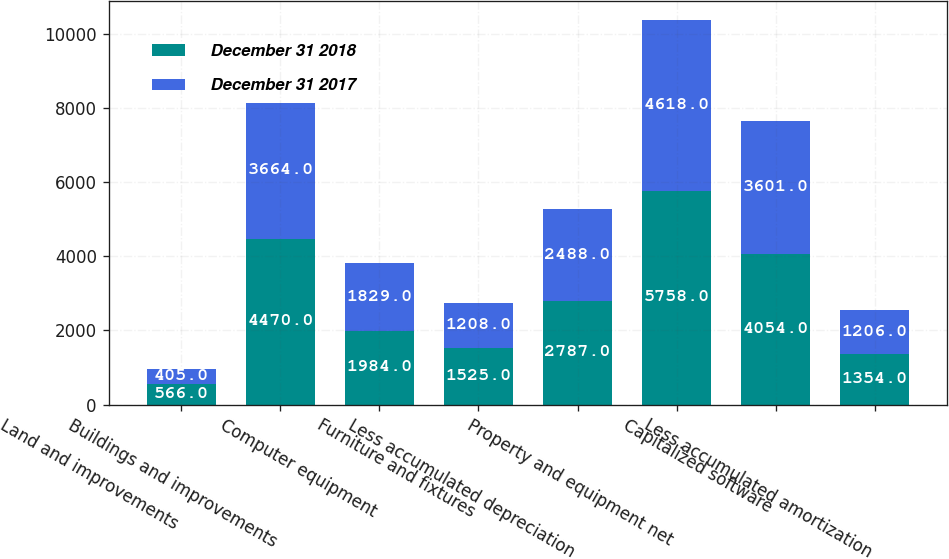<chart> <loc_0><loc_0><loc_500><loc_500><stacked_bar_chart><ecel><fcel>Land and improvements<fcel>Buildings and improvements<fcel>Computer equipment<fcel>Furniture and fixtures<fcel>Less accumulated depreciation<fcel>Property and equipment net<fcel>Capitalized software<fcel>Less accumulated amortization<nl><fcel>December 31 2018<fcel>566<fcel>4470<fcel>1984<fcel>1525<fcel>2787<fcel>5758<fcel>4054<fcel>1354<nl><fcel>December 31 2017<fcel>405<fcel>3664<fcel>1829<fcel>1208<fcel>2488<fcel>4618<fcel>3601<fcel>1206<nl></chart> 